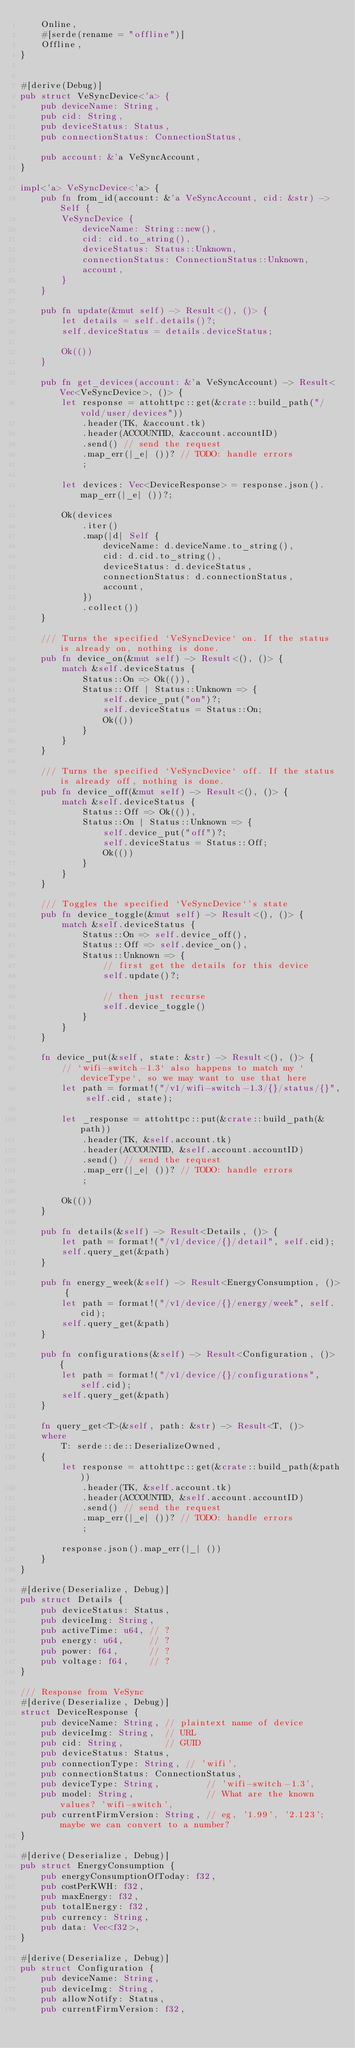Convert code to text. <code><loc_0><loc_0><loc_500><loc_500><_Rust_>    Online,
    #[serde(rename = "offline")]
    Offline,
}


#[derive(Debug)]
pub struct VeSyncDevice<'a> {
    pub deviceName: String,
    pub cid: String,
    pub deviceStatus: Status,
    pub connectionStatus: ConnectionStatus,

    pub account: &'a VeSyncAccount,
}

impl<'a> VeSyncDevice<'a> {
    pub fn from_id(account: &'a VeSyncAccount, cid: &str) -> Self {
        VeSyncDevice {
            deviceName: String::new(),
            cid: cid.to_string(),
            deviceStatus: Status::Unknown,
            connectionStatus: ConnectionStatus::Unknown,
            account,
        }
    }

    pub fn update(&mut self) -> Result<(), ()> {
        let details = self.details()?;
        self.deviceStatus = details.deviceStatus;

        Ok(())
    }

    pub fn get_devices(account: &'a VeSyncAccount) -> Result<Vec<VeSyncDevice>, ()> {
        let response = attohttpc::get(&crate::build_path("/vold/user/devices"))
            .header(TK, &account.tk)
            .header(ACCOUNTID, &account.accountID)
            .send() // send the request
            .map_err(|_e| ())? // TODO: handle errors
            ;

        let devices: Vec<DeviceResponse> = response.json().map_err(|_e| ())?;

        Ok(devices
            .iter()
            .map(|d| Self {
                deviceName: d.deviceName.to_string(),
                cid: d.cid.to_string(),
                deviceStatus: d.deviceStatus,
                connectionStatus: d.connectionStatus,
                account,
            })
            .collect())
    }

    /// Turns the specified `VeSyncDevice` on. If the status is already on, nothing is done.
    pub fn device_on(&mut self) -> Result<(), ()> {
        match &self.deviceStatus {
            Status::On => Ok(()),
            Status::Off | Status::Unknown => {
                self.device_put("on")?;
                self.deviceStatus = Status::On;
                Ok(())
            }
        }
    }

    /// Turns the specified `VeSyncDevice` off. If the status is already off, nothing is done.
    pub fn device_off(&mut self) -> Result<(), ()> {
        match &self.deviceStatus {
            Status::Off => Ok(()),
            Status::On | Status::Unknown => {
                self.device_put("off")?;
                self.deviceStatus = Status::Off;
                Ok(())
            }
        }
    }

    /// Toggles the specified `VeSyncDevice`'s state
    pub fn device_toggle(&mut self) -> Result<(), ()> {
        match &self.deviceStatus {
            Status::On => self.device_off(),
            Status::Off => self.device_on(),
            Status::Unknown => {
                // first get the details for this device
                self.update()?;

                // then just recurse
                self.device_toggle()
            }
        }
    }

    fn device_put(&self, state: &str) -> Result<(), ()> {
        // `wifi-switch-1.3` also happens to match my `deviceType`, so we may want to use that here
        let path = format!("/v1/wifi-switch-1.3/{}/status/{}", self.cid, state);

        let _response = attohttpc::put(&crate::build_path(&path))
            .header(TK, &self.account.tk)
            .header(ACCOUNTID, &self.account.accountID)
            .send() // send the request
            .map_err(|_e| ())? // TODO: handle errors
            ;

        Ok(())
    }

    pub fn details(&self) -> Result<Details, ()> {
        let path = format!("/v1/device/{}/detail", self.cid);
        self.query_get(&path)
    }

    pub fn energy_week(&self) -> Result<EnergyConsumption, ()> {
        let path = format!("/v1/device/{}/energy/week", self.cid);
        self.query_get(&path)
    }

    pub fn configurations(&self) -> Result<Configuration, ()> {
        let path = format!("/v1/device/{}/configurations", self.cid);
        self.query_get(&path)
    }

    fn query_get<T>(&self, path: &str) -> Result<T, ()>
    where
        T: serde::de::DeserializeOwned,
    {
        let response = attohttpc::get(&crate::build_path(&path))
            .header(TK, &self.account.tk)
            .header(ACCOUNTID, &self.account.accountID)
            .send() // send the request
            .map_err(|_e| ())? // TODO: handle errors
            ;

        response.json().map_err(|_| ())
    }
}

#[derive(Deserialize, Debug)]
pub struct Details {
    pub deviceStatus: Status,
    pub deviceImg: String,
    pub activeTime: u64, // ?
    pub energy: u64,     // ?
    pub power: f64,      // ?
    pub voltage: f64,    // ?
}

/// Response from VeSync
#[derive(Deserialize, Debug)]
struct DeviceResponse {
    pub deviceName: String, // plaintext name of device
    pub deviceImg: String,  // URL
    pub cid: String,        // GUID
    pub deviceStatus: Status,
    pub connectionType: String, // 'wifi',
    pub connectionStatus: ConnectionStatus,
    pub deviceType: String,         // 'wifi-switch-1.3',
    pub model: String,              // What are the known values? 'wifi-switch',
    pub currentFirmVersion: String, // eg, '1.99', '2.123'; maybe we can convert to a number?
}

#[derive(Deserialize, Debug)]
pub struct EnergyConsumption {
    pub energyConsumptionOfToday: f32,
    pub costPerKWH: f32,
    pub maxEnergy: f32,
    pub totalEnergy: f32,
    pub currency: String,
    pub data: Vec<f32>,
}

#[derive(Deserialize, Debug)]
pub struct Configuration {
    pub deviceName: String,
    pub deviceImg: String,
    pub allowNotify: Status,
    pub currentFirmVersion: f32,</code> 